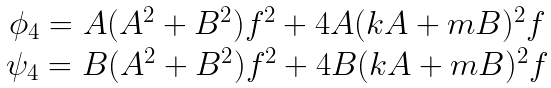Convert formula to latex. <formula><loc_0><loc_0><loc_500><loc_500>\begin{array} { c } \phi _ { 4 } = A ( A ^ { 2 } + B ^ { 2 } ) f ^ { 2 } + 4 A ( k A + m B ) ^ { 2 } f \\ \psi _ { 4 } = B ( A ^ { 2 } + B ^ { 2 } ) f ^ { 2 } + 4 B ( k A + m B ) ^ { 2 } f \\ \end{array}</formula> 